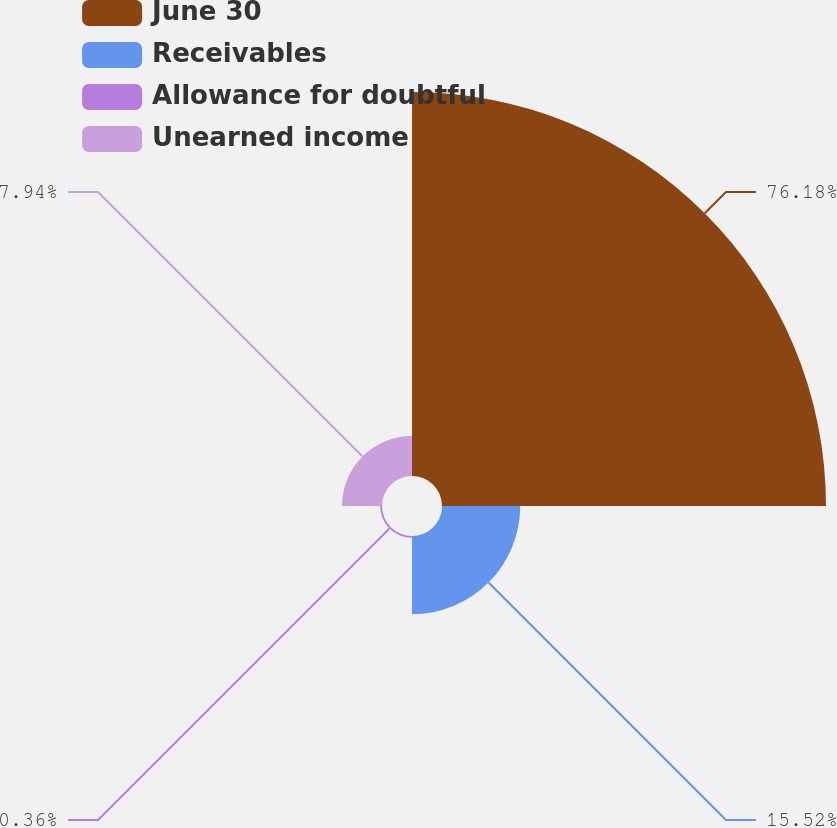<chart> <loc_0><loc_0><loc_500><loc_500><pie_chart><fcel>June 30<fcel>Receivables<fcel>Allowance for doubtful<fcel>Unearned income<nl><fcel>76.18%<fcel>15.52%<fcel>0.36%<fcel>7.94%<nl></chart> 